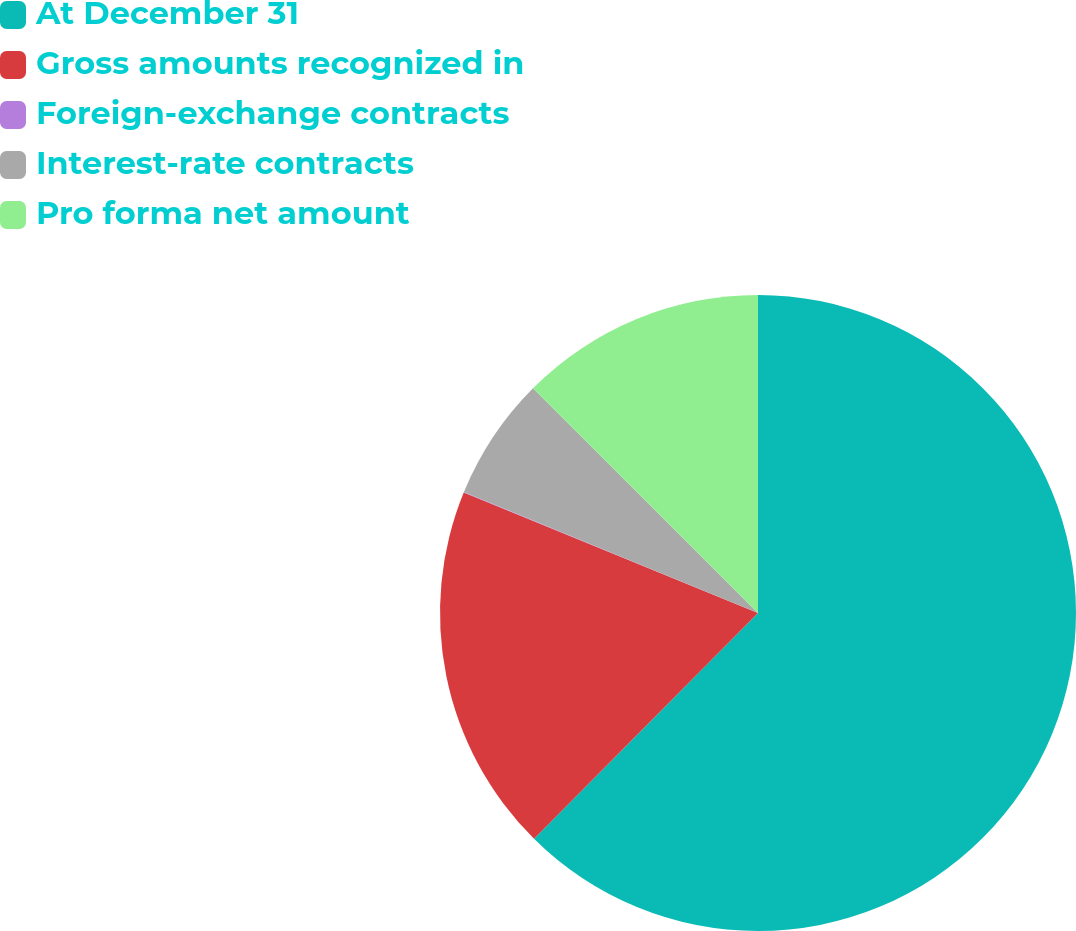Convert chart. <chart><loc_0><loc_0><loc_500><loc_500><pie_chart><fcel>At December 31<fcel>Gross amounts recognized in<fcel>Foreign-exchange contracts<fcel>Interest-rate contracts<fcel>Pro forma net amount<nl><fcel>62.43%<fcel>18.75%<fcel>0.03%<fcel>6.27%<fcel>12.51%<nl></chart> 